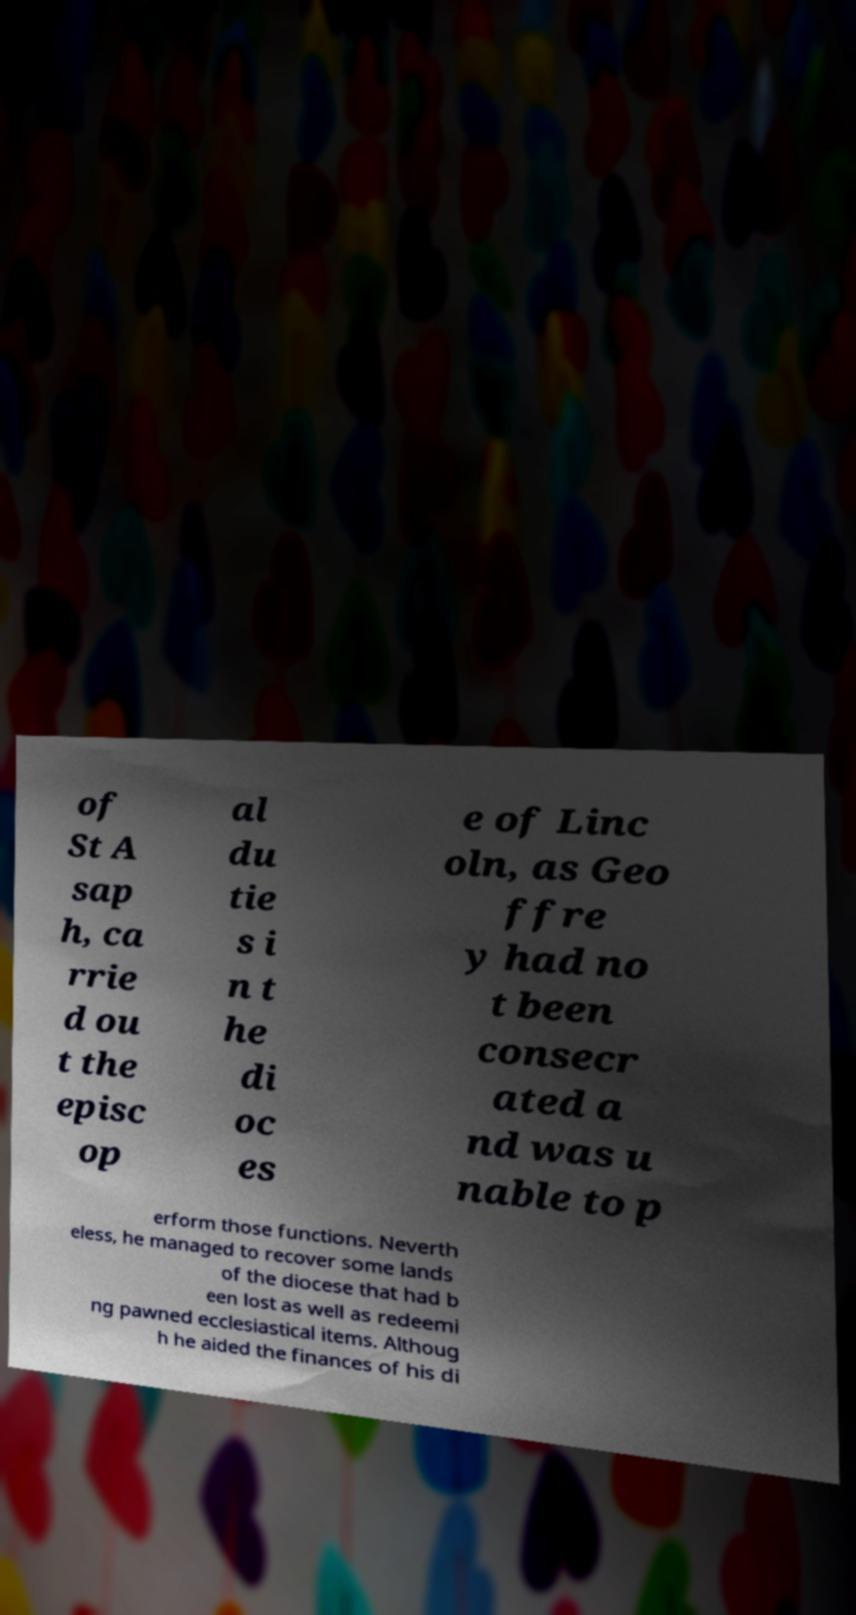What messages or text are displayed in this image? I need them in a readable, typed format. of St A sap h, ca rrie d ou t the episc op al du tie s i n t he di oc es e of Linc oln, as Geo ffre y had no t been consecr ated a nd was u nable to p erform those functions. Neverth eless, he managed to recover some lands of the diocese that had b een lost as well as redeemi ng pawned ecclesiastical items. Althoug h he aided the finances of his di 